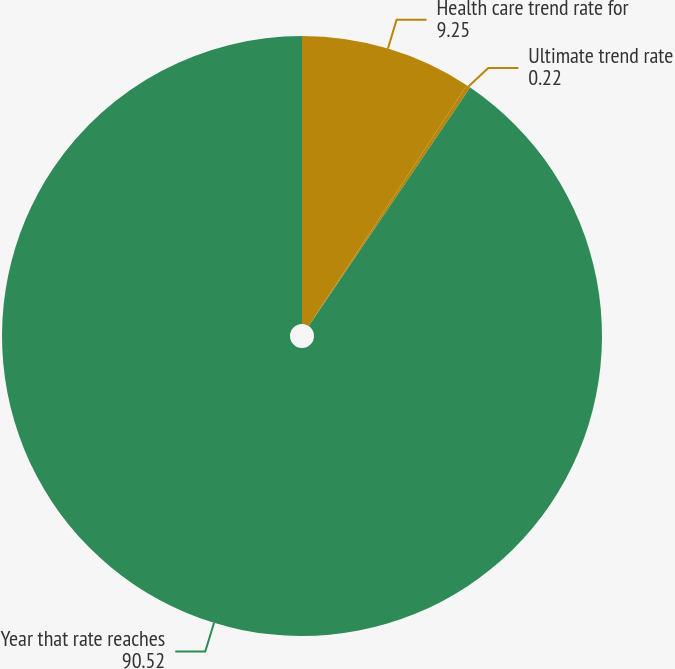Convert chart to OTSL. <chart><loc_0><loc_0><loc_500><loc_500><pie_chart><fcel>Health care trend rate for<fcel>Ultimate trend rate<fcel>Year that rate reaches<nl><fcel>9.25%<fcel>0.22%<fcel>90.52%<nl></chart> 